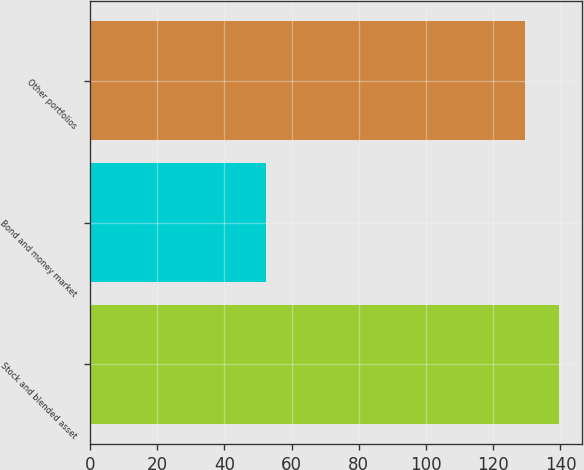Convert chart. <chart><loc_0><loc_0><loc_500><loc_500><bar_chart><fcel>Stock and blended asset<fcel>Bond and money market<fcel>Other portfolios<nl><fcel>139.5<fcel>52.3<fcel>129.5<nl></chart> 